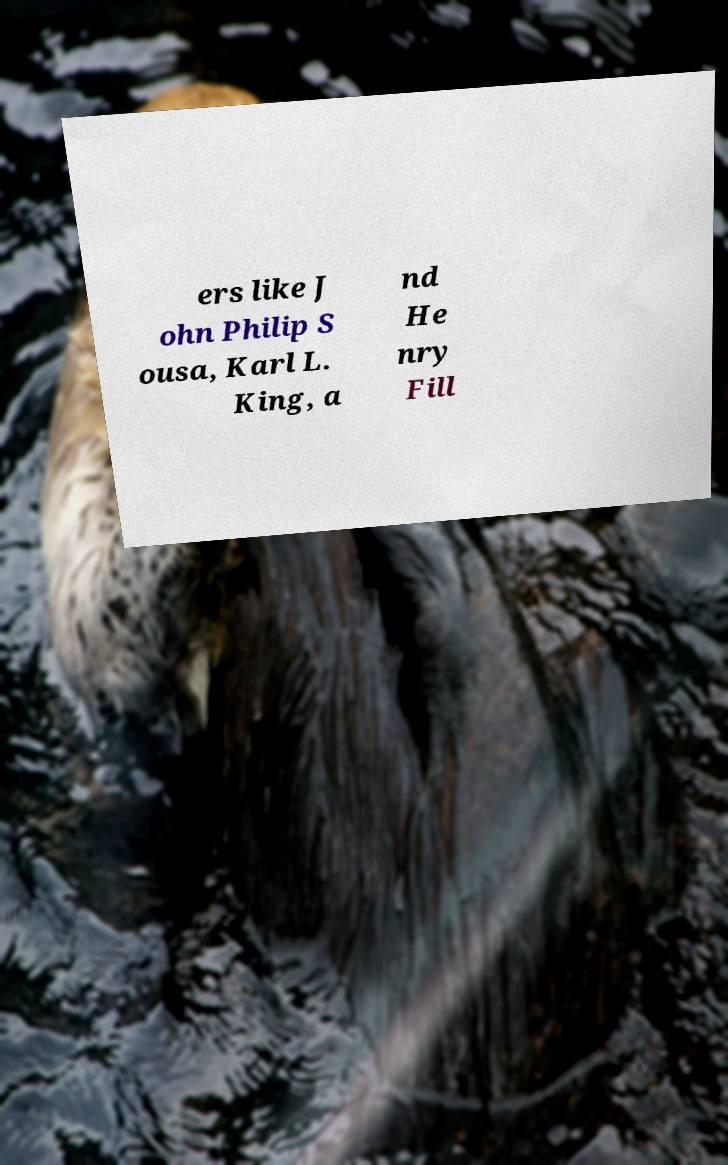I need the written content from this picture converted into text. Can you do that? ers like J ohn Philip S ousa, Karl L. King, a nd He nry Fill 